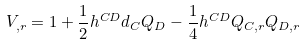Convert formula to latex. <formula><loc_0><loc_0><loc_500><loc_500>V _ { , r } = 1 + \frac { 1 } { 2 } h ^ { C D } d _ { C } Q _ { D } - \frac { 1 } { 4 } h ^ { C D } Q _ { C , r } Q _ { D , r }</formula> 